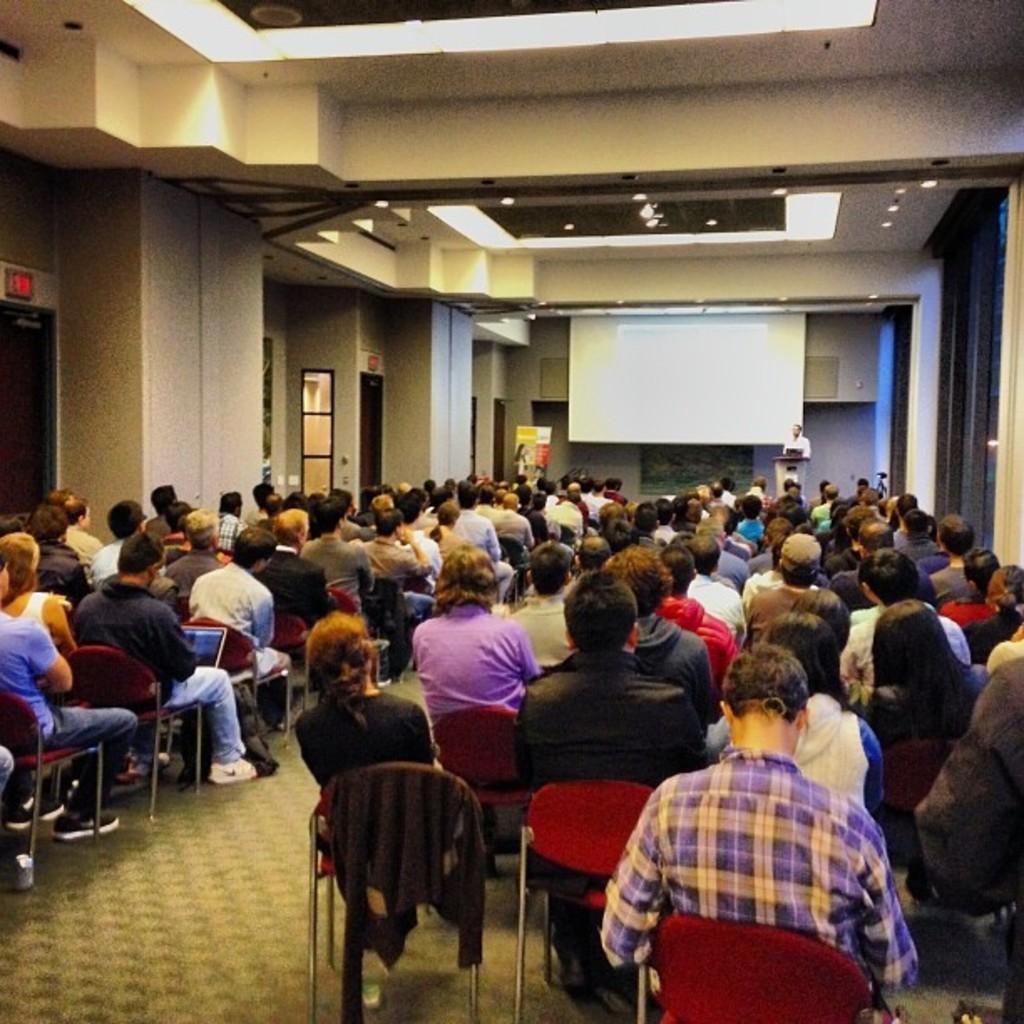Could you give a brief overview of what you see in this image? There are groups of people sitting on the chairs. This looks like a screen. Here is a person standing near the podium. I think this is a banner. I think these are the ceiling lights. I think these are the doors. I can see a person holding a laptop. 